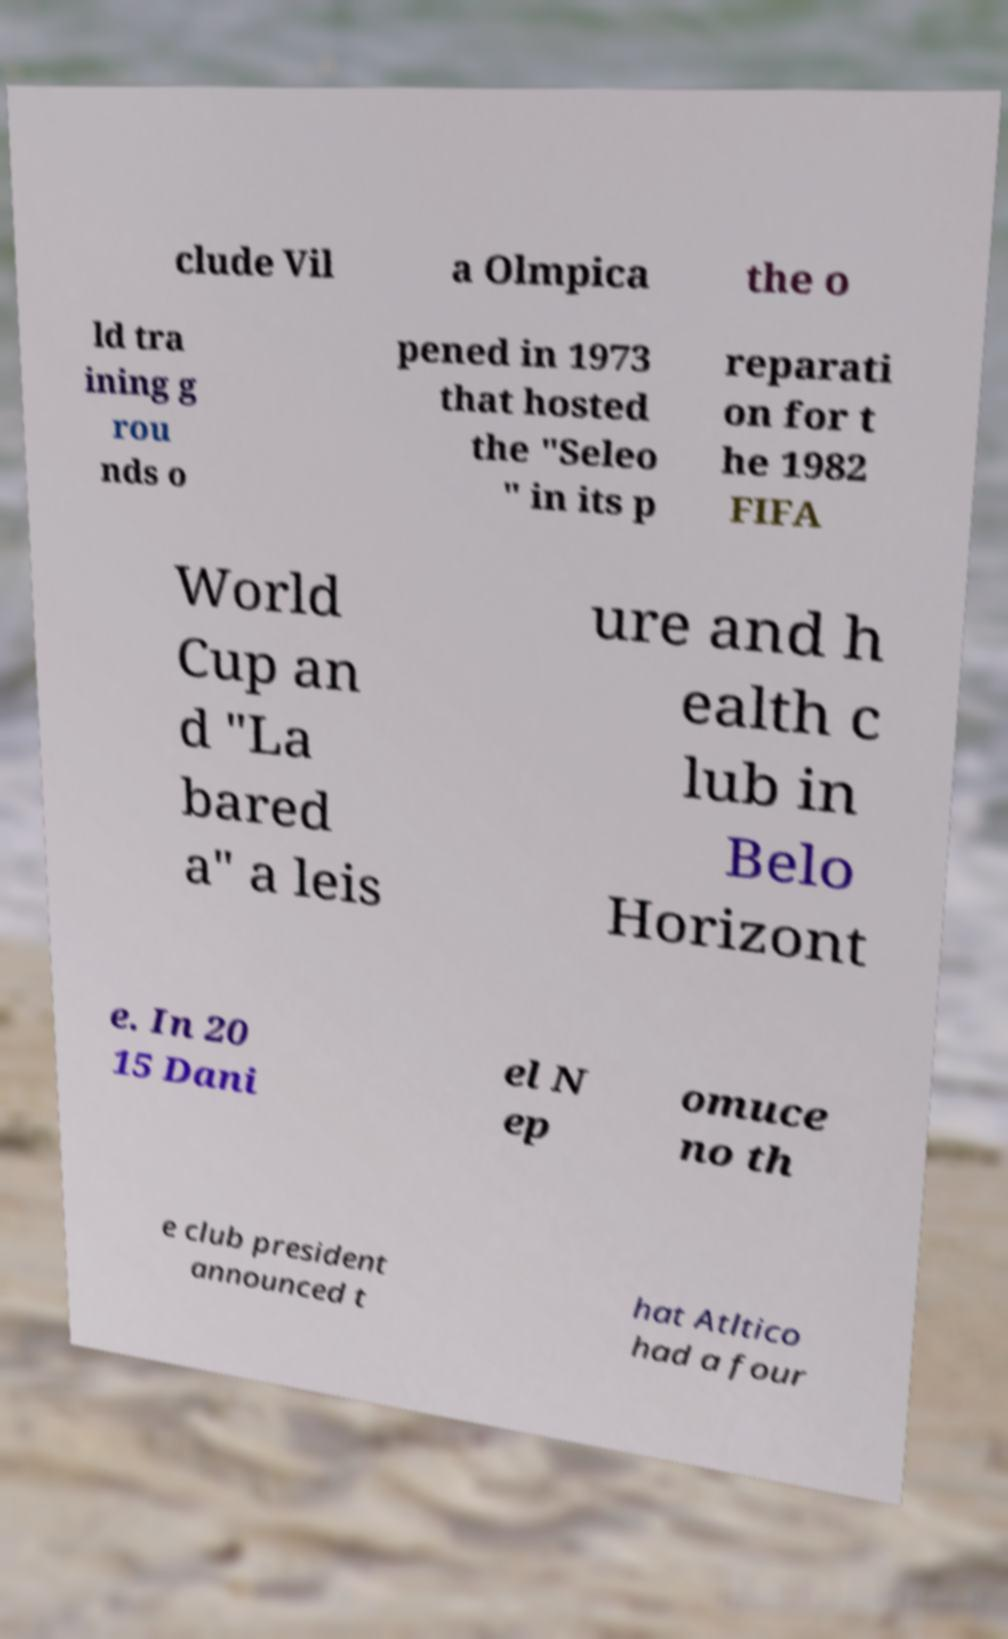Please read and relay the text visible in this image. What does it say? clude Vil a Olmpica the o ld tra ining g rou nds o pened in 1973 that hosted the "Seleo " in its p reparati on for t he 1982 FIFA World Cup an d "La bared a" a leis ure and h ealth c lub in Belo Horizont e. In 20 15 Dani el N ep omuce no th e club president announced t hat Atltico had a four 